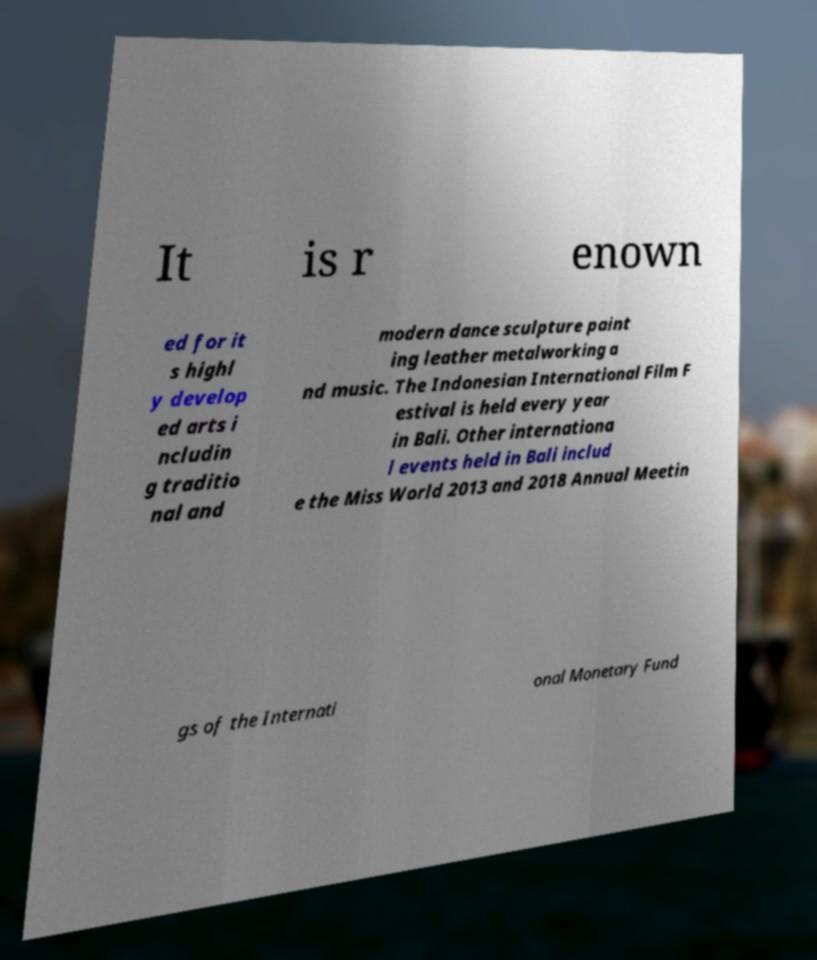I need the written content from this picture converted into text. Can you do that? It is r enown ed for it s highl y develop ed arts i ncludin g traditio nal and modern dance sculpture paint ing leather metalworking a nd music. The Indonesian International Film F estival is held every year in Bali. Other internationa l events held in Bali includ e the Miss World 2013 and 2018 Annual Meetin gs of the Internati onal Monetary Fund 